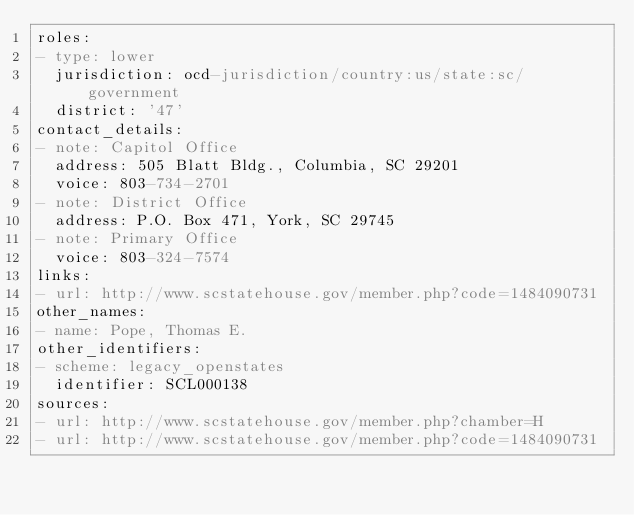Convert code to text. <code><loc_0><loc_0><loc_500><loc_500><_YAML_>roles:
- type: lower
  jurisdiction: ocd-jurisdiction/country:us/state:sc/government
  district: '47'
contact_details:
- note: Capitol Office
  address: 505 Blatt Bldg., Columbia, SC 29201
  voice: 803-734-2701
- note: District Office
  address: P.O. Box 471, York, SC 29745
- note: Primary Office
  voice: 803-324-7574
links:
- url: http://www.scstatehouse.gov/member.php?code=1484090731
other_names:
- name: Pope, Thomas E.
other_identifiers:
- scheme: legacy_openstates
  identifier: SCL000138
sources:
- url: http://www.scstatehouse.gov/member.php?chamber=H
- url: http://www.scstatehouse.gov/member.php?code=1484090731
</code> 